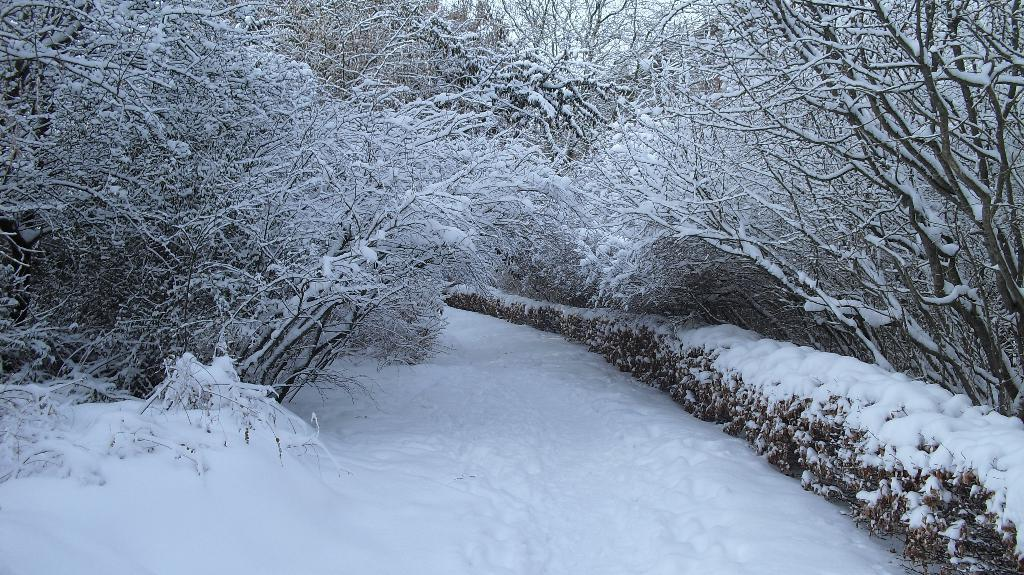What type of vegetation can be seen in the image? There are trees and plants in the image. What is the weather like in the image? There is snow in the image, which suggests a cold or wintery environment. What type of rifle can be seen in the image? There is no rifle present in the image. What type of voyage is depicted in the image? There is no voyage depicted in the image; it features trees, plants, and snow. 